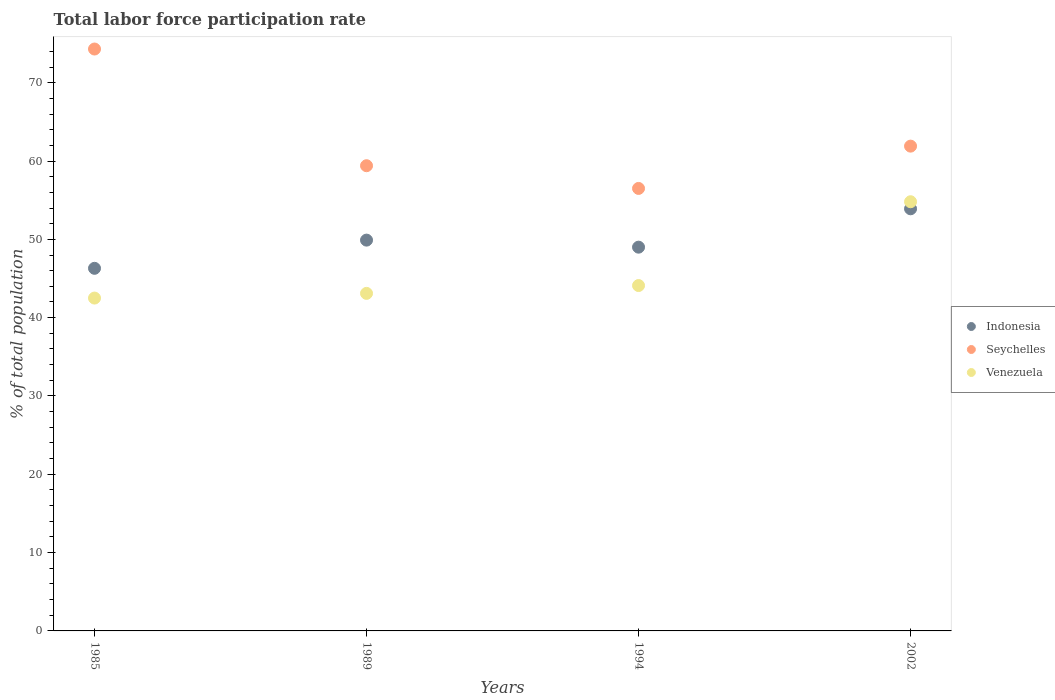Is the number of dotlines equal to the number of legend labels?
Offer a very short reply. Yes. What is the total labor force participation rate in Seychelles in 2002?
Your answer should be very brief. 61.9. Across all years, what is the maximum total labor force participation rate in Indonesia?
Ensure brevity in your answer.  53.9. Across all years, what is the minimum total labor force participation rate in Indonesia?
Ensure brevity in your answer.  46.3. What is the total total labor force participation rate in Indonesia in the graph?
Your answer should be very brief. 199.1. What is the difference between the total labor force participation rate in Venezuela in 1994 and that in 2002?
Provide a short and direct response. -10.7. What is the difference between the total labor force participation rate in Indonesia in 2002 and the total labor force participation rate in Venezuela in 1994?
Make the answer very short. 9.8. What is the average total labor force participation rate in Venezuela per year?
Ensure brevity in your answer.  46.12. In the year 1985, what is the difference between the total labor force participation rate in Indonesia and total labor force participation rate in Venezuela?
Make the answer very short. 3.8. What is the ratio of the total labor force participation rate in Indonesia in 1994 to that in 2002?
Your answer should be very brief. 0.91. Is the difference between the total labor force participation rate in Indonesia in 1985 and 2002 greater than the difference between the total labor force participation rate in Venezuela in 1985 and 2002?
Ensure brevity in your answer.  Yes. What is the difference between the highest and the lowest total labor force participation rate in Seychelles?
Offer a terse response. 17.8. Is the sum of the total labor force participation rate in Indonesia in 1989 and 1994 greater than the maximum total labor force participation rate in Venezuela across all years?
Your answer should be compact. Yes. Is it the case that in every year, the sum of the total labor force participation rate in Indonesia and total labor force participation rate in Venezuela  is greater than the total labor force participation rate in Seychelles?
Your response must be concise. Yes. Does the total labor force participation rate in Indonesia monotonically increase over the years?
Offer a very short reply. No. Is the total labor force participation rate in Venezuela strictly less than the total labor force participation rate in Seychelles over the years?
Offer a terse response. Yes. How many dotlines are there?
Ensure brevity in your answer.  3. Are the values on the major ticks of Y-axis written in scientific E-notation?
Give a very brief answer. No. Does the graph contain any zero values?
Give a very brief answer. No. Does the graph contain grids?
Your answer should be compact. No. Where does the legend appear in the graph?
Provide a short and direct response. Center right. How are the legend labels stacked?
Offer a very short reply. Vertical. What is the title of the graph?
Your answer should be compact. Total labor force participation rate. Does "Togo" appear as one of the legend labels in the graph?
Your answer should be very brief. No. What is the label or title of the X-axis?
Make the answer very short. Years. What is the label or title of the Y-axis?
Your answer should be compact. % of total population. What is the % of total population in Indonesia in 1985?
Your answer should be compact. 46.3. What is the % of total population of Seychelles in 1985?
Offer a terse response. 74.3. What is the % of total population of Venezuela in 1985?
Give a very brief answer. 42.5. What is the % of total population of Indonesia in 1989?
Provide a succinct answer. 49.9. What is the % of total population in Seychelles in 1989?
Provide a succinct answer. 59.4. What is the % of total population in Venezuela in 1989?
Provide a short and direct response. 43.1. What is the % of total population in Seychelles in 1994?
Provide a succinct answer. 56.5. What is the % of total population of Venezuela in 1994?
Provide a short and direct response. 44.1. What is the % of total population of Indonesia in 2002?
Your answer should be very brief. 53.9. What is the % of total population of Seychelles in 2002?
Make the answer very short. 61.9. What is the % of total population of Venezuela in 2002?
Provide a succinct answer. 54.8. Across all years, what is the maximum % of total population in Indonesia?
Provide a short and direct response. 53.9. Across all years, what is the maximum % of total population of Seychelles?
Your answer should be compact. 74.3. Across all years, what is the maximum % of total population in Venezuela?
Keep it short and to the point. 54.8. Across all years, what is the minimum % of total population in Indonesia?
Ensure brevity in your answer.  46.3. Across all years, what is the minimum % of total population of Seychelles?
Give a very brief answer. 56.5. Across all years, what is the minimum % of total population of Venezuela?
Ensure brevity in your answer.  42.5. What is the total % of total population of Indonesia in the graph?
Offer a terse response. 199.1. What is the total % of total population in Seychelles in the graph?
Give a very brief answer. 252.1. What is the total % of total population of Venezuela in the graph?
Provide a short and direct response. 184.5. What is the difference between the % of total population of Venezuela in 1985 and that in 1989?
Provide a short and direct response. -0.6. What is the difference between the % of total population of Indonesia in 1985 and that in 1994?
Ensure brevity in your answer.  -2.7. What is the difference between the % of total population of Venezuela in 1985 and that in 1994?
Make the answer very short. -1.6. What is the difference between the % of total population of Seychelles in 1985 and that in 2002?
Provide a succinct answer. 12.4. What is the difference between the % of total population in Indonesia in 1989 and that in 1994?
Provide a succinct answer. 0.9. What is the difference between the % of total population of Seychelles in 1989 and that in 1994?
Your answer should be very brief. 2.9. What is the difference between the % of total population of Venezuela in 1989 and that in 2002?
Your response must be concise. -11.7. What is the difference between the % of total population in Indonesia in 1985 and the % of total population in Seychelles in 1989?
Ensure brevity in your answer.  -13.1. What is the difference between the % of total population of Seychelles in 1985 and the % of total population of Venezuela in 1989?
Give a very brief answer. 31.2. What is the difference between the % of total population in Seychelles in 1985 and the % of total population in Venezuela in 1994?
Provide a succinct answer. 30.2. What is the difference between the % of total population of Indonesia in 1985 and the % of total population of Seychelles in 2002?
Offer a very short reply. -15.6. What is the difference between the % of total population of Indonesia in 1989 and the % of total population of Venezuela in 1994?
Provide a succinct answer. 5.8. What is the difference between the % of total population in Seychelles in 1989 and the % of total population in Venezuela in 1994?
Your answer should be very brief. 15.3. What is the difference between the % of total population in Indonesia in 1989 and the % of total population in Seychelles in 2002?
Provide a succinct answer. -12. What is the difference between the % of total population of Seychelles in 1989 and the % of total population of Venezuela in 2002?
Your response must be concise. 4.6. What is the difference between the % of total population of Indonesia in 1994 and the % of total population of Venezuela in 2002?
Your answer should be compact. -5.8. What is the average % of total population of Indonesia per year?
Offer a very short reply. 49.77. What is the average % of total population in Seychelles per year?
Ensure brevity in your answer.  63.02. What is the average % of total population in Venezuela per year?
Your answer should be very brief. 46.12. In the year 1985, what is the difference between the % of total population in Seychelles and % of total population in Venezuela?
Your answer should be very brief. 31.8. In the year 1989, what is the difference between the % of total population in Indonesia and % of total population in Venezuela?
Your answer should be very brief. 6.8. In the year 1994, what is the difference between the % of total population of Indonesia and % of total population of Venezuela?
Your response must be concise. 4.9. What is the ratio of the % of total population of Indonesia in 1985 to that in 1989?
Make the answer very short. 0.93. What is the ratio of the % of total population in Seychelles in 1985 to that in 1989?
Offer a very short reply. 1.25. What is the ratio of the % of total population in Venezuela in 1985 to that in 1989?
Make the answer very short. 0.99. What is the ratio of the % of total population in Indonesia in 1985 to that in 1994?
Your response must be concise. 0.94. What is the ratio of the % of total population in Seychelles in 1985 to that in 1994?
Offer a terse response. 1.31. What is the ratio of the % of total population of Venezuela in 1985 to that in 1994?
Provide a succinct answer. 0.96. What is the ratio of the % of total population of Indonesia in 1985 to that in 2002?
Make the answer very short. 0.86. What is the ratio of the % of total population in Seychelles in 1985 to that in 2002?
Provide a short and direct response. 1.2. What is the ratio of the % of total population in Venezuela in 1985 to that in 2002?
Make the answer very short. 0.78. What is the ratio of the % of total population in Indonesia in 1989 to that in 1994?
Ensure brevity in your answer.  1.02. What is the ratio of the % of total population in Seychelles in 1989 to that in 1994?
Make the answer very short. 1.05. What is the ratio of the % of total population of Venezuela in 1989 to that in 1994?
Keep it short and to the point. 0.98. What is the ratio of the % of total population in Indonesia in 1989 to that in 2002?
Provide a short and direct response. 0.93. What is the ratio of the % of total population of Seychelles in 1989 to that in 2002?
Provide a short and direct response. 0.96. What is the ratio of the % of total population of Venezuela in 1989 to that in 2002?
Give a very brief answer. 0.79. What is the ratio of the % of total population of Indonesia in 1994 to that in 2002?
Your answer should be very brief. 0.91. What is the ratio of the % of total population in Seychelles in 1994 to that in 2002?
Make the answer very short. 0.91. What is the ratio of the % of total population of Venezuela in 1994 to that in 2002?
Provide a short and direct response. 0.8. What is the difference between the highest and the second highest % of total population of Seychelles?
Offer a terse response. 12.4. What is the difference between the highest and the second highest % of total population of Venezuela?
Keep it short and to the point. 10.7. What is the difference between the highest and the lowest % of total population in Venezuela?
Make the answer very short. 12.3. 